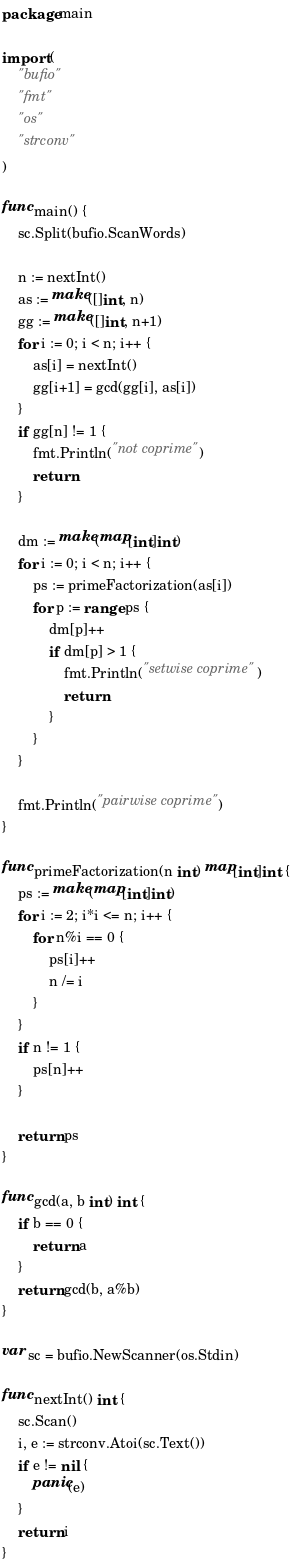<code> <loc_0><loc_0><loc_500><loc_500><_Go_>package main

import (
	"bufio"
	"fmt"
	"os"
	"strconv"
)

func main() {
	sc.Split(bufio.ScanWords)

	n := nextInt()
	as := make([]int, n)
	gg := make([]int, n+1)
	for i := 0; i < n; i++ {
		as[i] = nextInt()
		gg[i+1] = gcd(gg[i], as[i])
	}
	if gg[n] != 1 {
		fmt.Println("not coprime")
		return
	}

	dm := make(map[int]int)
	for i := 0; i < n; i++ {
		ps := primeFactorization(as[i])
		for p := range ps {
			dm[p]++
			if dm[p] > 1 {
				fmt.Println("setwise coprime")
				return
			}
		}
	}

	fmt.Println("pairwise coprime")
}

func primeFactorization(n int) map[int]int {
	ps := make(map[int]int)
	for i := 2; i*i <= n; i++ {
		for n%i == 0 {
			ps[i]++
			n /= i
		}
	}
	if n != 1 {
		ps[n]++
	}

	return ps
}

func gcd(a, b int) int {
	if b == 0 {
		return a
	}
	return gcd(b, a%b)
}

var sc = bufio.NewScanner(os.Stdin)

func nextInt() int {
	sc.Scan()
	i, e := strconv.Atoi(sc.Text())
	if e != nil {
		panic(e)
	}
	return i
}
</code> 